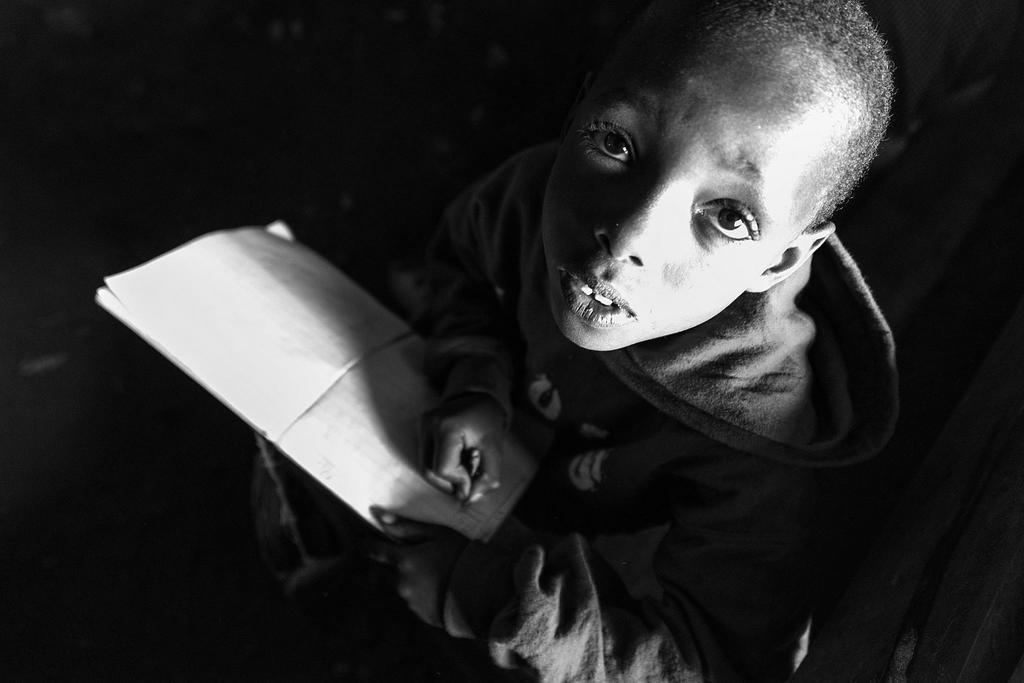What is the color scheme of the image? The image is black and white. Who is present in the image? There is a boy in the image. What is the boy holding in his hands? The boy is holding a book and a pencil. How many kittens are playing with the pencil in the image? There are no kittens present in the image, and therefore no such activity can be observed. 